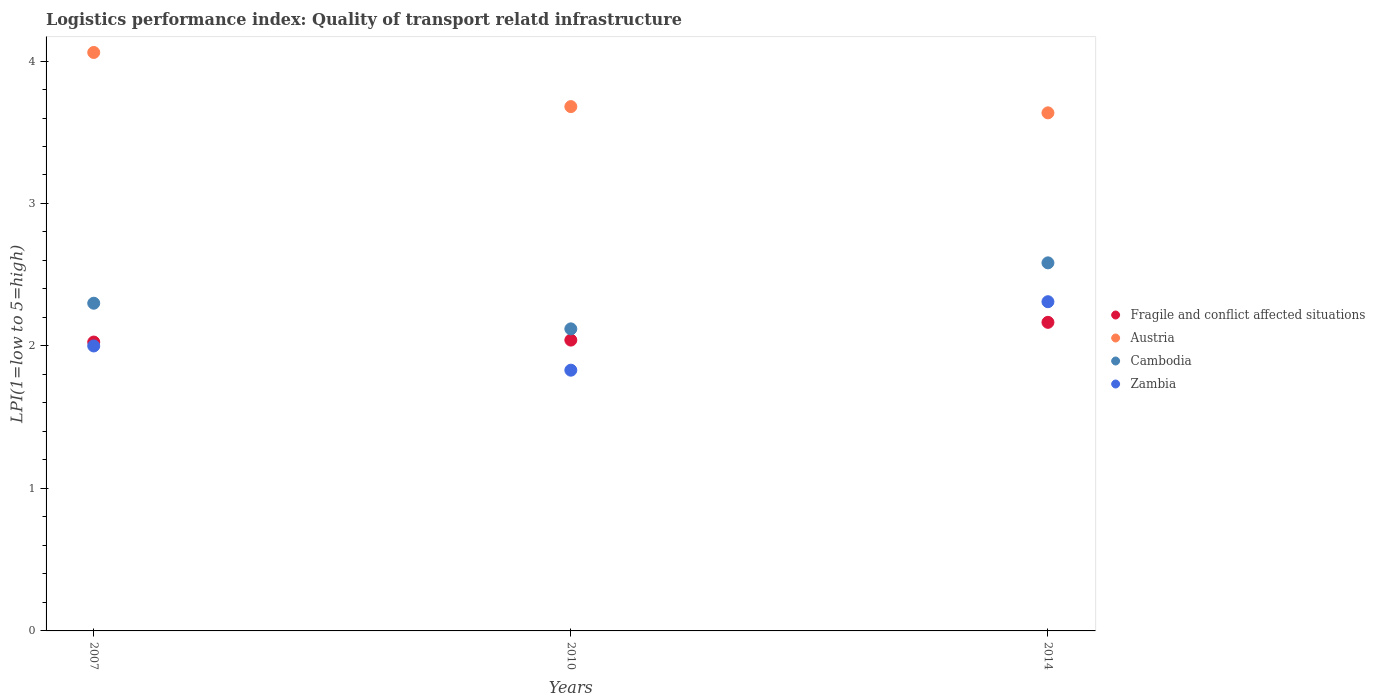How many different coloured dotlines are there?
Ensure brevity in your answer.  4. Is the number of dotlines equal to the number of legend labels?
Give a very brief answer. Yes. Across all years, what is the maximum logistics performance index in Austria?
Ensure brevity in your answer.  4.06. Across all years, what is the minimum logistics performance index in Cambodia?
Offer a very short reply. 2.12. In which year was the logistics performance index in Zambia maximum?
Provide a succinct answer. 2014. In which year was the logistics performance index in Zambia minimum?
Your answer should be compact. 2010. What is the total logistics performance index in Fragile and conflict affected situations in the graph?
Make the answer very short. 6.23. What is the difference between the logistics performance index in Fragile and conflict affected situations in 2007 and that in 2010?
Ensure brevity in your answer.  -0.01. What is the difference between the logistics performance index in Fragile and conflict affected situations in 2014 and the logistics performance index in Austria in 2007?
Your response must be concise. -1.89. What is the average logistics performance index in Fragile and conflict affected situations per year?
Your answer should be compact. 2.08. In the year 2007, what is the difference between the logistics performance index in Cambodia and logistics performance index in Fragile and conflict affected situations?
Offer a terse response. 0.27. What is the ratio of the logistics performance index in Austria in 2007 to that in 2010?
Offer a terse response. 1.1. What is the difference between the highest and the second highest logistics performance index in Fragile and conflict affected situations?
Your response must be concise. 0.12. What is the difference between the highest and the lowest logistics performance index in Cambodia?
Offer a terse response. 0.46. Is the sum of the logistics performance index in Zambia in 2007 and 2010 greater than the maximum logistics performance index in Fragile and conflict affected situations across all years?
Give a very brief answer. Yes. Is it the case that in every year, the sum of the logistics performance index in Cambodia and logistics performance index in Zambia  is greater than the logistics performance index in Austria?
Keep it short and to the point. Yes. Is the logistics performance index in Austria strictly greater than the logistics performance index in Fragile and conflict affected situations over the years?
Ensure brevity in your answer.  Yes. Is the logistics performance index in Fragile and conflict affected situations strictly less than the logistics performance index in Cambodia over the years?
Keep it short and to the point. Yes. How many years are there in the graph?
Keep it short and to the point. 3. Does the graph contain any zero values?
Offer a very short reply. No. How many legend labels are there?
Offer a very short reply. 4. How are the legend labels stacked?
Make the answer very short. Vertical. What is the title of the graph?
Ensure brevity in your answer.  Logistics performance index: Quality of transport relatd infrastructure. Does "Channel Islands" appear as one of the legend labels in the graph?
Offer a very short reply. No. What is the label or title of the X-axis?
Provide a short and direct response. Years. What is the label or title of the Y-axis?
Give a very brief answer. LPI(1=low to 5=high). What is the LPI(1=low to 5=high) of Fragile and conflict affected situations in 2007?
Offer a very short reply. 2.03. What is the LPI(1=low to 5=high) of Austria in 2007?
Ensure brevity in your answer.  4.06. What is the LPI(1=low to 5=high) of Cambodia in 2007?
Your response must be concise. 2.3. What is the LPI(1=low to 5=high) of Zambia in 2007?
Your answer should be compact. 2. What is the LPI(1=low to 5=high) of Fragile and conflict affected situations in 2010?
Offer a terse response. 2.04. What is the LPI(1=low to 5=high) of Austria in 2010?
Offer a terse response. 3.68. What is the LPI(1=low to 5=high) of Cambodia in 2010?
Provide a succinct answer. 2.12. What is the LPI(1=low to 5=high) of Zambia in 2010?
Offer a very short reply. 1.83. What is the LPI(1=low to 5=high) of Fragile and conflict affected situations in 2014?
Keep it short and to the point. 2.17. What is the LPI(1=low to 5=high) in Austria in 2014?
Make the answer very short. 3.64. What is the LPI(1=low to 5=high) of Cambodia in 2014?
Give a very brief answer. 2.58. What is the LPI(1=low to 5=high) in Zambia in 2014?
Give a very brief answer. 2.31. Across all years, what is the maximum LPI(1=low to 5=high) of Fragile and conflict affected situations?
Your answer should be very brief. 2.17. Across all years, what is the maximum LPI(1=low to 5=high) of Austria?
Provide a short and direct response. 4.06. Across all years, what is the maximum LPI(1=low to 5=high) in Cambodia?
Keep it short and to the point. 2.58. Across all years, what is the maximum LPI(1=low to 5=high) of Zambia?
Ensure brevity in your answer.  2.31. Across all years, what is the minimum LPI(1=low to 5=high) in Fragile and conflict affected situations?
Offer a terse response. 2.03. Across all years, what is the minimum LPI(1=low to 5=high) in Austria?
Keep it short and to the point. 3.64. Across all years, what is the minimum LPI(1=low to 5=high) of Cambodia?
Keep it short and to the point. 2.12. Across all years, what is the minimum LPI(1=low to 5=high) in Zambia?
Give a very brief answer. 1.83. What is the total LPI(1=low to 5=high) of Fragile and conflict affected situations in the graph?
Your answer should be very brief. 6.23. What is the total LPI(1=low to 5=high) of Austria in the graph?
Make the answer very short. 11.38. What is the total LPI(1=low to 5=high) in Cambodia in the graph?
Provide a succinct answer. 7. What is the total LPI(1=low to 5=high) of Zambia in the graph?
Ensure brevity in your answer.  6.14. What is the difference between the LPI(1=low to 5=high) of Fragile and conflict affected situations in 2007 and that in 2010?
Your response must be concise. -0.01. What is the difference between the LPI(1=low to 5=high) of Austria in 2007 and that in 2010?
Offer a very short reply. 0.38. What is the difference between the LPI(1=low to 5=high) in Cambodia in 2007 and that in 2010?
Offer a terse response. 0.18. What is the difference between the LPI(1=low to 5=high) of Zambia in 2007 and that in 2010?
Your response must be concise. 0.17. What is the difference between the LPI(1=low to 5=high) in Fragile and conflict affected situations in 2007 and that in 2014?
Offer a terse response. -0.14. What is the difference between the LPI(1=low to 5=high) of Austria in 2007 and that in 2014?
Your answer should be very brief. 0.42. What is the difference between the LPI(1=low to 5=high) in Cambodia in 2007 and that in 2014?
Offer a terse response. -0.28. What is the difference between the LPI(1=low to 5=high) in Zambia in 2007 and that in 2014?
Offer a terse response. -0.31. What is the difference between the LPI(1=low to 5=high) in Fragile and conflict affected situations in 2010 and that in 2014?
Make the answer very short. -0.12. What is the difference between the LPI(1=low to 5=high) in Austria in 2010 and that in 2014?
Provide a short and direct response. 0.04. What is the difference between the LPI(1=low to 5=high) of Cambodia in 2010 and that in 2014?
Make the answer very short. -0.46. What is the difference between the LPI(1=low to 5=high) in Zambia in 2010 and that in 2014?
Offer a very short reply. -0.48. What is the difference between the LPI(1=low to 5=high) in Fragile and conflict affected situations in 2007 and the LPI(1=low to 5=high) in Austria in 2010?
Make the answer very short. -1.65. What is the difference between the LPI(1=low to 5=high) in Fragile and conflict affected situations in 2007 and the LPI(1=low to 5=high) in Cambodia in 2010?
Keep it short and to the point. -0.09. What is the difference between the LPI(1=low to 5=high) in Fragile and conflict affected situations in 2007 and the LPI(1=low to 5=high) in Zambia in 2010?
Provide a short and direct response. 0.2. What is the difference between the LPI(1=low to 5=high) in Austria in 2007 and the LPI(1=low to 5=high) in Cambodia in 2010?
Provide a short and direct response. 1.94. What is the difference between the LPI(1=low to 5=high) of Austria in 2007 and the LPI(1=low to 5=high) of Zambia in 2010?
Your answer should be very brief. 2.23. What is the difference between the LPI(1=low to 5=high) of Cambodia in 2007 and the LPI(1=low to 5=high) of Zambia in 2010?
Give a very brief answer. 0.47. What is the difference between the LPI(1=low to 5=high) in Fragile and conflict affected situations in 2007 and the LPI(1=low to 5=high) in Austria in 2014?
Offer a terse response. -1.61. What is the difference between the LPI(1=low to 5=high) of Fragile and conflict affected situations in 2007 and the LPI(1=low to 5=high) of Cambodia in 2014?
Offer a terse response. -0.56. What is the difference between the LPI(1=low to 5=high) in Fragile and conflict affected situations in 2007 and the LPI(1=low to 5=high) in Zambia in 2014?
Your answer should be compact. -0.28. What is the difference between the LPI(1=low to 5=high) in Austria in 2007 and the LPI(1=low to 5=high) in Cambodia in 2014?
Offer a terse response. 1.48. What is the difference between the LPI(1=low to 5=high) of Austria in 2007 and the LPI(1=low to 5=high) of Zambia in 2014?
Your answer should be compact. 1.75. What is the difference between the LPI(1=low to 5=high) of Cambodia in 2007 and the LPI(1=low to 5=high) of Zambia in 2014?
Offer a very short reply. -0.01. What is the difference between the LPI(1=low to 5=high) of Fragile and conflict affected situations in 2010 and the LPI(1=low to 5=high) of Austria in 2014?
Provide a succinct answer. -1.59. What is the difference between the LPI(1=low to 5=high) in Fragile and conflict affected situations in 2010 and the LPI(1=low to 5=high) in Cambodia in 2014?
Offer a terse response. -0.54. What is the difference between the LPI(1=low to 5=high) of Fragile and conflict affected situations in 2010 and the LPI(1=low to 5=high) of Zambia in 2014?
Offer a very short reply. -0.27. What is the difference between the LPI(1=low to 5=high) in Austria in 2010 and the LPI(1=low to 5=high) in Cambodia in 2014?
Offer a very short reply. 1.1. What is the difference between the LPI(1=low to 5=high) of Austria in 2010 and the LPI(1=low to 5=high) of Zambia in 2014?
Provide a short and direct response. 1.37. What is the difference between the LPI(1=low to 5=high) of Cambodia in 2010 and the LPI(1=low to 5=high) of Zambia in 2014?
Provide a short and direct response. -0.19. What is the average LPI(1=low to 5=high) of Fragile and conflict affected situations per year?
Keep it short and to the point. 2.08. What is the average LPI(1=low to 5=high) in Austria per year?
Provide a short and direct response. 3.79. What is the average LPI(1=low to 5=high) in Cambodia per year?
Give a very brief answer. 2.33. What is the average LPI(1=low to 5=high) in Zambia per year?
Give a very brief answer. 2.05. In the year 2007, what is the difference between the LPI(1=low to 5=high) in Fragile and conflict affected situations and LPI(1=low to 5=high) in Austria?
Offer a terse response. -2.03. In the year 2007, what is the difference between the LPI(1=low to 5=high) of Fragile and conflict affected situations and LPI(1=low to 5=high) of Cambodia?
Make the answer very short. -0.27. In the year 2007, what is the difference between the LPI(1=low to 5=high) of Fragile and conflict affected situations and LPI(1=low to 5=high) of Zambia?
Offer a terse response. 0.03. In the year 2007, what is the difference between the LPI(1=low to 5=high) in Austria and LPI(1=low to 5=high) in Cambodia?
Offer a terse response. 1.76. In the year 2007, what is the difference between the LPI(1=low to 5=high) of Austria and LPI(1=low to 5=high) of Zambia?
Your answer should be compact. 2.06. In the year 2010, what is the difference between the LPI(1=low to 5=high) of Fragile and conflict affected situations and LPI(1=low to 5=high) of Austria?
Ensure brevity in your answer.  -1.64. In the year 2010, what is the difference between the LPI(1=low to 5=high) in Fragile and conflict affected situations and LPI(1=low to 5=high) in Cambodia?
Provide a short and direct response. -0.08. In the year 2010, what is the difference between the LPI(1=low to 5=high) in Fragile and conflict affected situations and LPI(1=low to 5=high) in Zambia?
Give a very brief answer. 0.21. In the year 2010, what is the difference between the LPI(1=low to 5=high) of Austria and LPI(1=low to 5=high) of Cambodia?
Your response must be concise. 1.56. In the year 2010, what is the difference between the LPI(1=low to 5=high) of Austria and LPI(1=low to 5=high) of Zambia?
Your answer should be compact. 1.85. In the year 2010, what is the difference between the LPI(1=low to 5=high) in Cambodia and LPI(1=low to 5=high) in Zambia?
Give a very brief answer. 0.29. In the year 2014, what is the difference between the LPI(1=low to 5=high) of Fragile and conflict affected situations and LPI(1=low to 5=high) of Austria?
Give a very brief answer. -1.47. In the year 2014, what is the difference between the LPI(1=low to 5=high) of Fragile and conflict affected situations and LPI(1=low to 5=high) of Cambodia?
Provide a succinct answer. -0.42. In the year 2014, what is the difference between the LPI(1=low to 5=high) in Fragile and conflict affected situations and LPI(1=low to 5=high) in Zambia?
Ensure brevity in your answer.  -0.14. In the year 2014, what is the difference between the LPI(1=low to 5=high) of Austria and LPI(1=low to 5=high) of Cambodia?
Make the answer very short. 1.05. In the year 2014, what is the difference between the LPI(1=low to 5=high) in Austria and LPI(1=low to 5=high) in Zambia?
Offer a terse response. 1.33. In the year 2014, what is the difference between the LPI(1=low to 5=high) of Cambodia and LPI(1=low to 5=high) of Zambia?
Provide a succinct answer. 0.27. What is the ratio of the LPI(1=low to 5=high) in Austria in 2007 to that in 2010?
Ensure brevity in your answer.  1.1. What is the ratio of the LPI(1=low to 5=high) of Cambodia in 2007 to that in 2010?
Provide a short and direct response. 1.08. What is the ratio of the LPI(1=low to 5=high) of Zambia in 2007 to that in 2010?
Your response must be concise. 1.09. What is the ratio of the LPI(1=low to 5=high) of Fragile and conflict affected situations in 2007 to that in 2014?
Your answer should be very brief. 0.94. What is the ratio of the LPI(1=low to 5=high) in Austria in 2007 to that in 2014?
Provide a succinct answer. 1.12. What is the ratio of the LPI(1=low to 5=high) in Cambodia in 2007 to that in 2014?
Keep it short and to the point. 0.89. What is the ratio of the LPI(1=low to 5=high) in Zambia in 2007 to that in 2014?
Ensure brevity in your answer.  0.87. What is the ratio of the LPI(1=low to 5=high) in Fragile and conflict affected situations in 2010 to that in 2014?
Your answer should be compact. 0.94. What is the ratio of the LPI(1=low to 5=high) in Austria in 2010 to that in 2014?
Your response must be concise. 1.01. What is the ratio of the LPI(1=low to 5=high) in Cambodia in 2010 to that in 2014?
Your answer should be very brief. 0.82. What is the ratio of the LPI(1=low to 5=high) of Zambia in 2010 to that in 2014?
Ensure brevity in your answer.  0.79. What is the difference between the highest and the second highest LPI(1=low to 5=high) in Fragile and conflict affected situations?
Offer a very short reply. 0.12. What is the difference between the highest and the second highest LPI(1=low to 5=high) of Austria?
Keep it short and to the point. 0.38. What is the difference between the highest and the second highest LPI(1=low to 5=high) in Cambodia?
Give a very brief answer. 0.28. What is the difference between the highest and the second highest LPI(1=low to 5=high) in Zambia?
Ensure brevity in your answer.  0.31. What is the difference between the highest and the lowest LPI(1=low to 5=high) in Fragile and conflict affected situations?
Make the answer very short. 0.14. What is the difference between the highest and the lowest LPI(1=low to 5=high) of Austria?
Your answer should be compact. 0.42. What is the difference between the highest and the lowest LPI(1=low to 5=high) of Cambodia?
Give a very brief answer. 0.46. What is the difference between the highest and the lowest LPI(1=low to 5=high) of Zambia?
Your answer should be very brief. 0.48. 